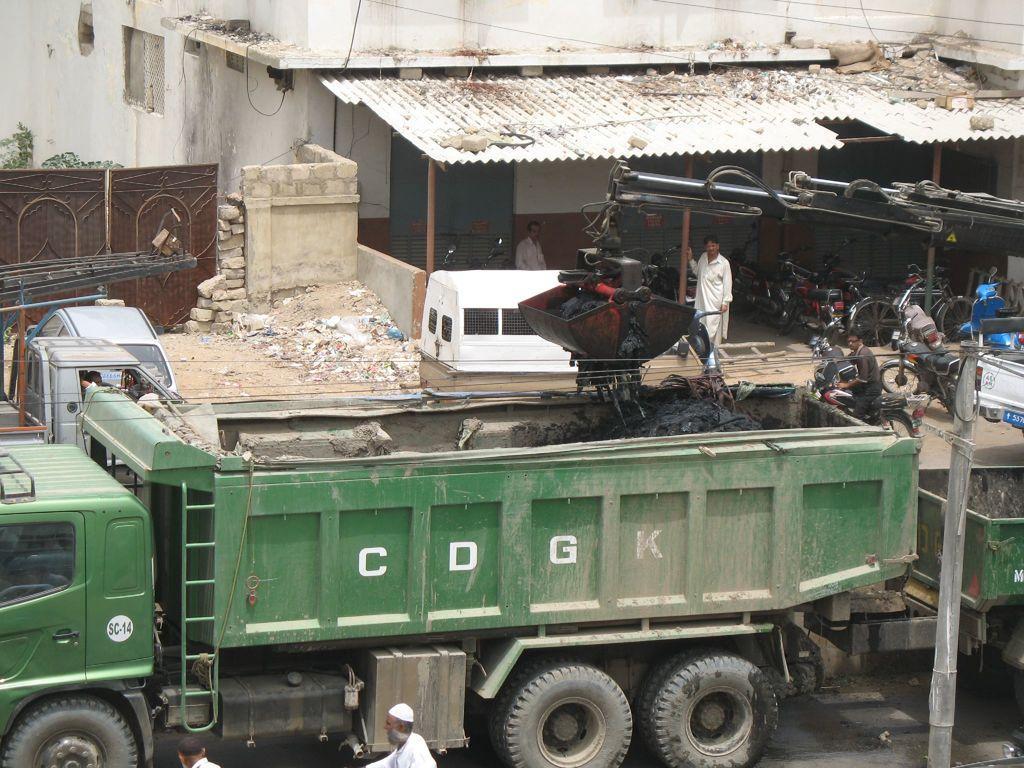In one or two sentences, can you explain what this image depicts? In this image we can see vehicles. Also there is a buildings with pillars and shutters. And we can see bucket of a crane with handle. Also there are motorcycles near to the building. And there are stones. 